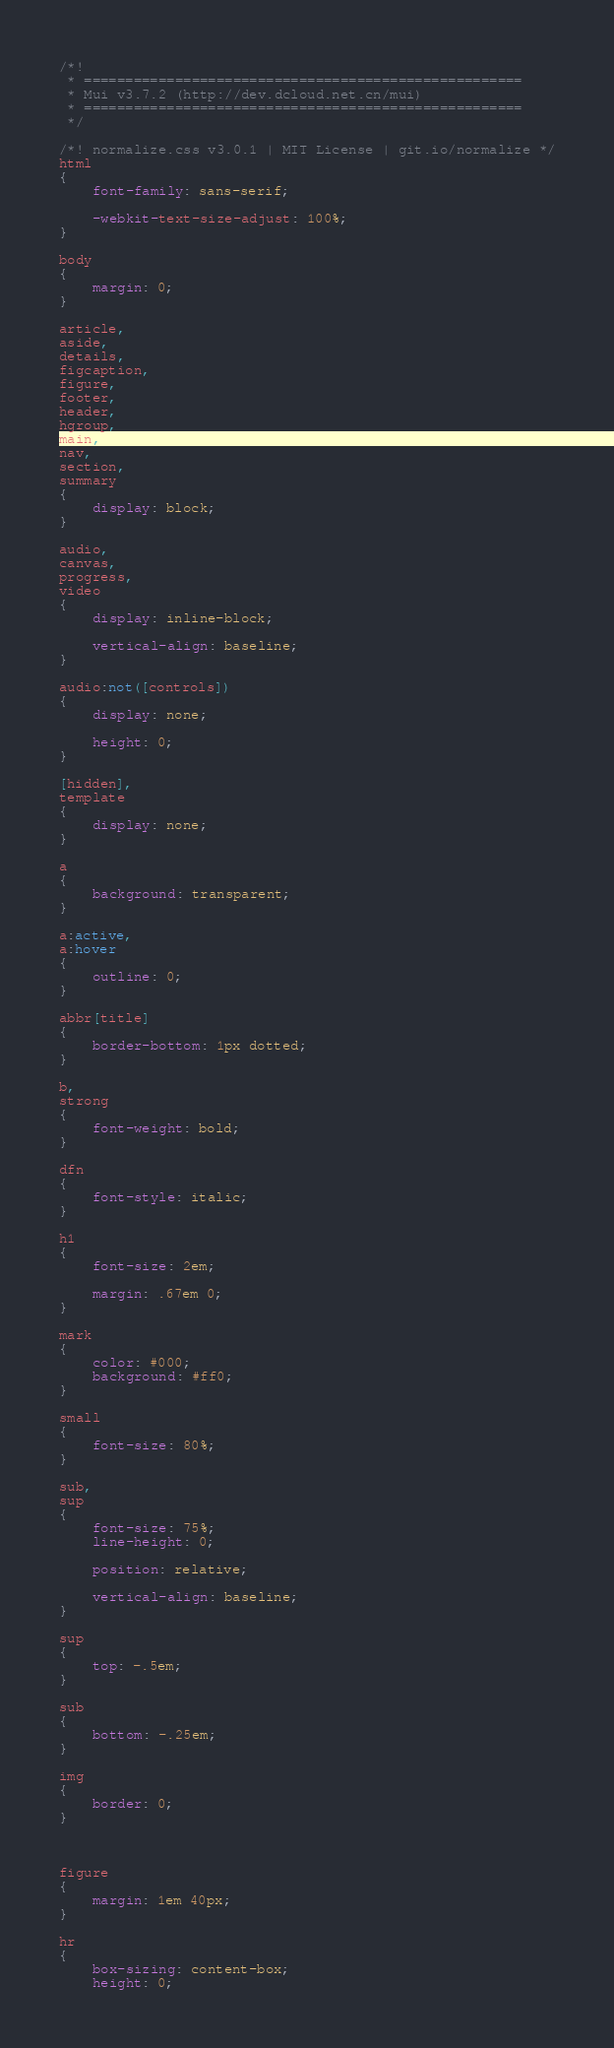<code> <loc_0><loc_0><loc_500><loc_500><_CSS_>/*!
 * =====================================================
 * Mui v3.7.2 (http://dev.dcloud.net.cn/mui)
 * =====================================================
 */

/*! normalize.css v3.0.1 | MIT License | git.io/normalize */
html
{
    font-family: sans-serif;

    -webkit-text-size-adjust: 100%;
}

body
{
    margin: 0;
}

article,
aside,
details,
figcaption,
figure,
footer,
header,
hgroup,
main,
nav,
section,
summary
{
    display: block;
}

audio,
canvas,
progress,
video
{
    display: inline-block;

    vertical-align: baseline;
}

audio:not([controls])
{
    display: none;

    height: 0;
}

[hidden],
template
{
    display: none;
}

a
{
    background: transparent;
}

a:active,
a:hover
{
    outline: 0;
}

abbr[title]
{
    border-bottom: 1px dotted;
}

b,
strong
{
    font-weight: bold;
}

dfn
{
    font-style: italic;
}

h1
{
    font-size: 2em;

    margin: .67em 0;
}

mark
{
    color: #000;
    background: #ff0;
}

small
{
    font-size: 80%;
}

sub,
sup
{
    font-size: 75%;
    line-height: 0;

    position: relative;

    vertical-align: baseline;
}

sup
{
    top: -.5em;
}

sub
{
    bottom: -.25em;
}

img
{
    border: 0;
}



figure
{
    margin: 1em 40px;
}

hr
{
    box-sizing: content-box;
    height: 0;</code> 